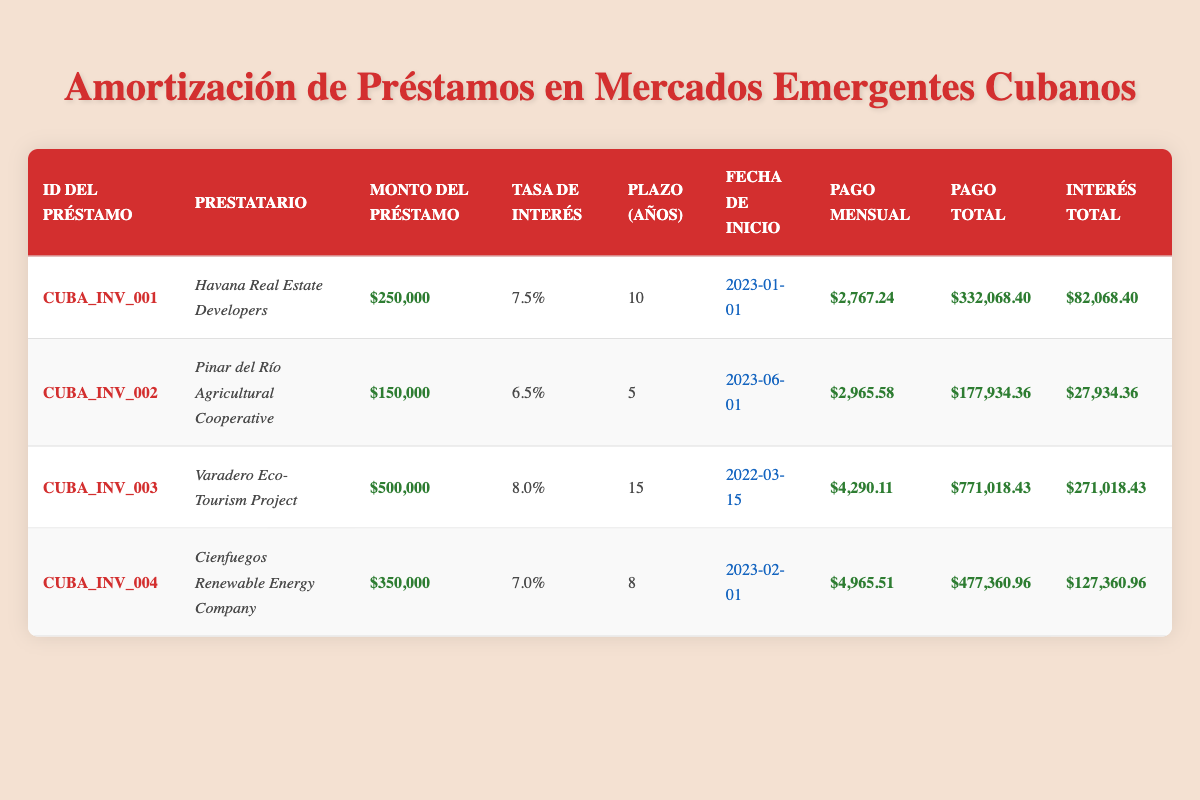¿Cuál es el monto total del préstamo de la Cooperativa Agrícola de Pinar del Río? En la tabla, bajo la columna "Monto del Préstamo" correspondiente a la fila de la Cooperativa Agrícola de Pinar del Río, el monto se indica claramente como $150,000.
Answer: 150,000 ¿Qué préstamo tiene la tasa de interés más alta? Observando la columna "Tasa de Interés", los valores son: 7.5% para el préstamo de Havana Real Estate Developers, 6.5% para la Cooperativa Agrícola, 8.0% para el Proyecto Eco-Turismo de Varadero, y 7.0% para la Empresa de Energía Renovable de Cienfuegos. El mayor valor es 8.0%, correspondiente al Proyecto Eco-Turismo de Varadero.
Answer: Proyecto Eco-Turismo de Varadero ¿Cuánto es el interés total pagado por el préstamo de Cienfuegos? En la columna "Interés Total" para el préstamo de la Empresa de Energía Renovable de Cienfuegos, se puede experimentar un pago total de $127,360.96, que se presenta directamente en la tabla.
Answer: 127,360.96 ¿Cuál es la diferencia entre el pago total del préstamo de los Desarrolladores Inmobiliarios de La Habana y del Proyecto Eco-Turismo de Varadero? Los pagos totales son $332,068.40 para los Desarrolladores Inmobiliarios de La Habana y $771,018.43 para el Proyecto Eco-Turismo de Varadero. La diferencia se calcula restando: $771,018.43 - $332,068.40 = $438,950.03.
Answer: 438,950.03 ¿Los Desarrolladores Inmobiliarios de La Habana iniciaron su préstamo antes que la Empresa de Energía Renovable de Cienfuegos? La fecha de inicio del préstamo de los Desarrolladores Inmobiliarios de La Habana es el 2023-01-01, mientras que el préstamo de la Empresa de Energía Renovable comenzó el 2023-02-01. Por lo tanto, el préstamo de La Habana comenzó antes.
Answer: Sí ¿Cuál es el promedio de los pagos mensuales de todos los préstamos? Los pagos mensuales son: $2,767.24 para La Habana, $2,965.58 para Pinar del Río, $4,290.11 para Varadero, y $4,965.51 para Cienfuegos. Sumando todos estos: $2,767.24 + $2,965.58 + $4,290.11 + $4,965.51 = $15,988.44. Entonces, el promedio sería $15,988.44 / 4 = $3,997.11.
Answer: 3,997.11 ¿Cuál préstamo tiene el plazo más corto? Al revisar la columna "Plazo (Años)", los plazos son 10, 5, 15 y 8 años. El menor valor es 5 años, correspondiente al préstamo de la Cooperativa Agrícola de Pinar del Río.
Answer: Cooperativa Agrícola de Pinar del Río 